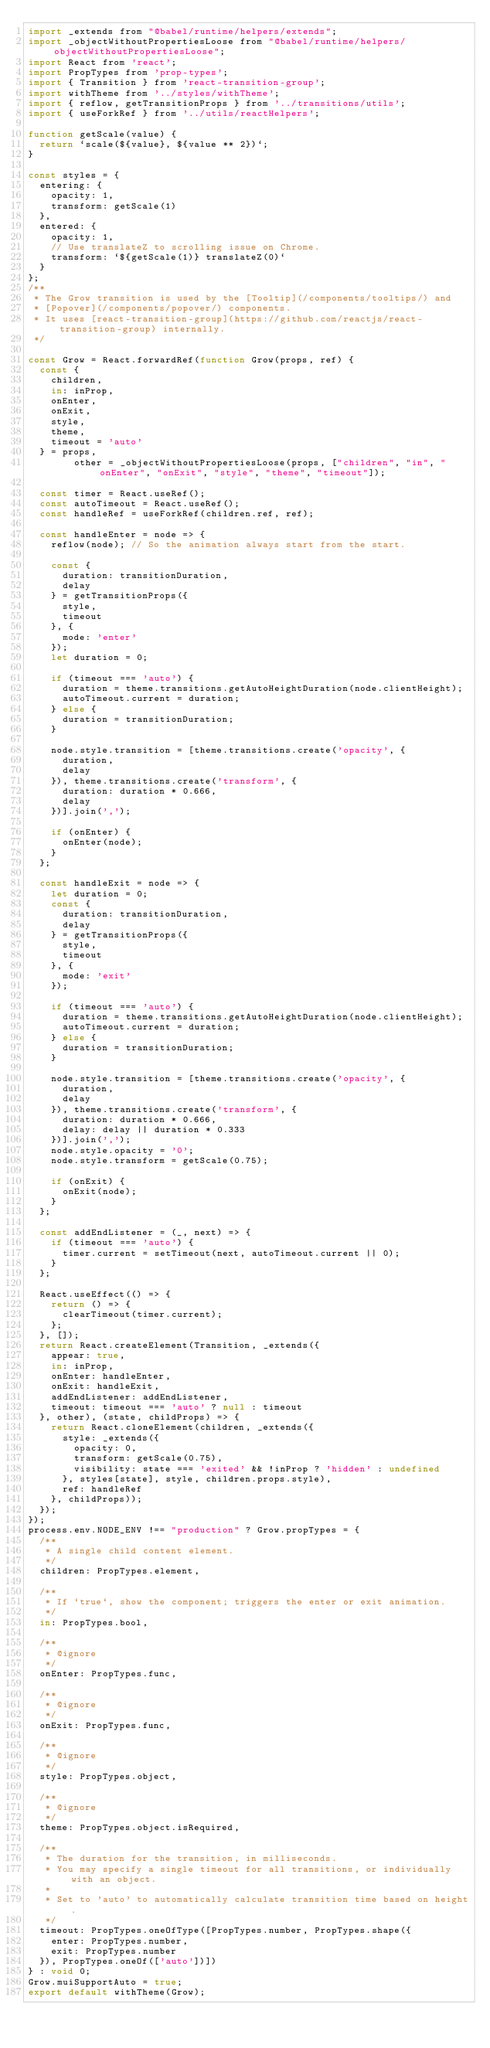Convert code to text. <code><loc_0><loc_0><loc_500><loc_500><_JavaScript_>import _extends from "@babel/runtime/helpers/extends";
import _objectWithoutPropertiesLoose from "@babel/runtime/helpers/objectWithoutPropertiesLoose";
import React from 'react';
import PropTypes from 'prop-types';
import { Transition } from 'react-transition-group';
import withTheme from '../styles/withTheme';
import { reflow, getTransitionProps } from '../transitions/utils';
import { useForkRef } from '../utils/reactHelpers';

function getScale(value) {
  return `scale(${value}, ${value ** 2})`;
}

const styles = {
  entering: {
    opacity: 1,
    transform: getScale(1)
  },
  entered: {
    opacity: 1,
    // Use translateZ to scrolling issue on Chrome.
    transform: `${getScale(1)} translateZ(0)`
  }
};
/**
 * The Grow transition is used by the [Tooltip](/components/tooltips/) and
 * [Popover](/components/popover/) components.
 * It uses [react-transition-group](https://github.com/reactjs/react-transition-group) internally.
 */

const Grow = React.forwardRef(function Grow(props, ref) {
  const {
    children,
    in: inProp,
    onEnter,
    onExit,
    style,
    theme,
    timeout = 'auto'
  } = props,
        other = _objectWithoutPropertiesLoose(props, ["children", "in", "onEnter", "onExit", "style", "theme", "timeout"]);

  const timer = React.useRef();
  const autoTimeout = React.useRef();
  const handleRef = useForkRef(children.ref, ref);

  const handleEnter = node => {
    reflow(node); // So the animation always start from the start.

    const {
      duration: transitionDuration,
      delay
    } = getTransitionProps({
      style,
      timeout
    }, {
      mode: 'enter'
    });
    let duration = 0;

    if (timeout === 'auto') {
      duration = theme.transitions.getAutoHeightDuration(node.clientHeight);
      autoTimeout.current = duration;
    } else {
      duration = transitionDuration;
    }

    node.style.transition = [theme.transitions.create('opacity', {
      duration,
      delay
    }), theme.transitions.create('transform', {
      duration: duration * 0.666,
      delay
    })].join(',');

    if (onEnter) {
      onEnter(node);
    }
  };

  const handleExit = node => {
    let duration = 0;
    const {
      duration: transitionDuration,
      delay
    } = getTransitionProps({
      style,
      timeout
    }, {
      mode: 'exit'
    });

    if (timeout === 'auto') {
      duration = theme.transitions.getAutoHeightDuration(node.clientHeight);
      autoTimeout.current = duration;
    } else {
      duration = transitionDuration;
    }

    node.style.transition = [theme.transitions.create('opacity', {
      duration,
      delay
    }), theme.transitions.create('transform', {
      duration: duration * 0.666,
      delay: delay || duration * 0.333
    })].join(',');
    node.style.opacity = '0';
    node.style.transform = getScale(0.75);

    if (onExit) {
      onExit(node);
    }
  };

  const addEndListener = (_, next) => {
    if (timeout === 'auto') {
      timer.current = setTimeout(next, autoTimeout.current || 0);
    }
  };

  React.useEffect(() => {
    return () => {
      clearTimeout(timer.current);
    };
  }, []);
  return React.createElement(Transition, _extends({
    appear: true,
    in: inProp,
    onEnter: handleEnter,
    onExit: handleExit,
    addEndListener: addEndListener,
    timeout: timeout === 'auto' ? null : timeout
  }, other), (state, childProps) => {
    return React.cloneElement(children, _extends({
      style: _extends({
        opacity: 0,
        transform: getScale(0.75),
        visibility: state === 'exited' && !inProp ? 'hidden' : undefined
      }, styles[state], style, children.props.style),
      ref: handleRef
    }, childProps));
  });
});
process.env.NODE_ENV !== "production" ? Grow.propTypes = {
  /**
   * A single child content element.
   */
  children: PropTypes.element,

  /**
   * If `true`, show the component; triggers the enter or exit animation.
   */
  in: PropTypes.bool,

  /**
   * @ignore
   */
  onEnter: PropTypes.func,

  /**
   * @ignore
   */
  onExit: PropTypes.func,

  /**
   * @ignore
   */
  style: PropTypes.object,

  /**
   * @ignore
   */
  theme: PropTypes.object.isRequired,

  /**
   * The duration for the transition, in milliseconds.
   * You may specify a single timeout for all transitions, or individually with an object.
   *
   * Set to 'auto' to automatically calculate transition time based on height.
   */
  timeout: PropTypes.oneOfType([PropTypes.number, PropTypes.shape({
    enter: PropTypes.number,
    exit: PropTypes.number
  }), PropTypes.oneOf(['auto'])])
} : void 0;
Grow.muiSupportAuto = true;
export default withTheme(Grow);</code> 